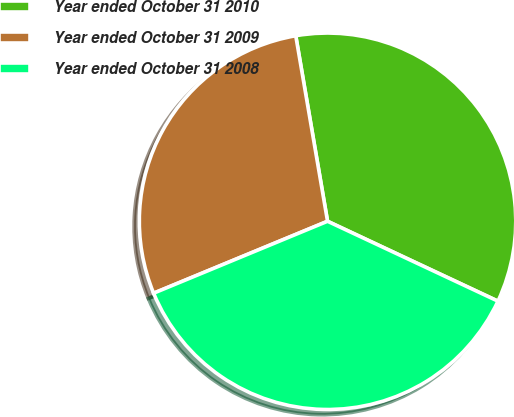Convert chart to OTSL. <chart><loc_0><loc_0><loc_500><loc_500><pie_chart><fcel>Year ended October 31 2010<fcel>Year ended October 31 2009<fcel>Year ended October 31 2008<nl><fcel>34.68%<fcel>28.54%<fcel>36.78%<nl></chart> 